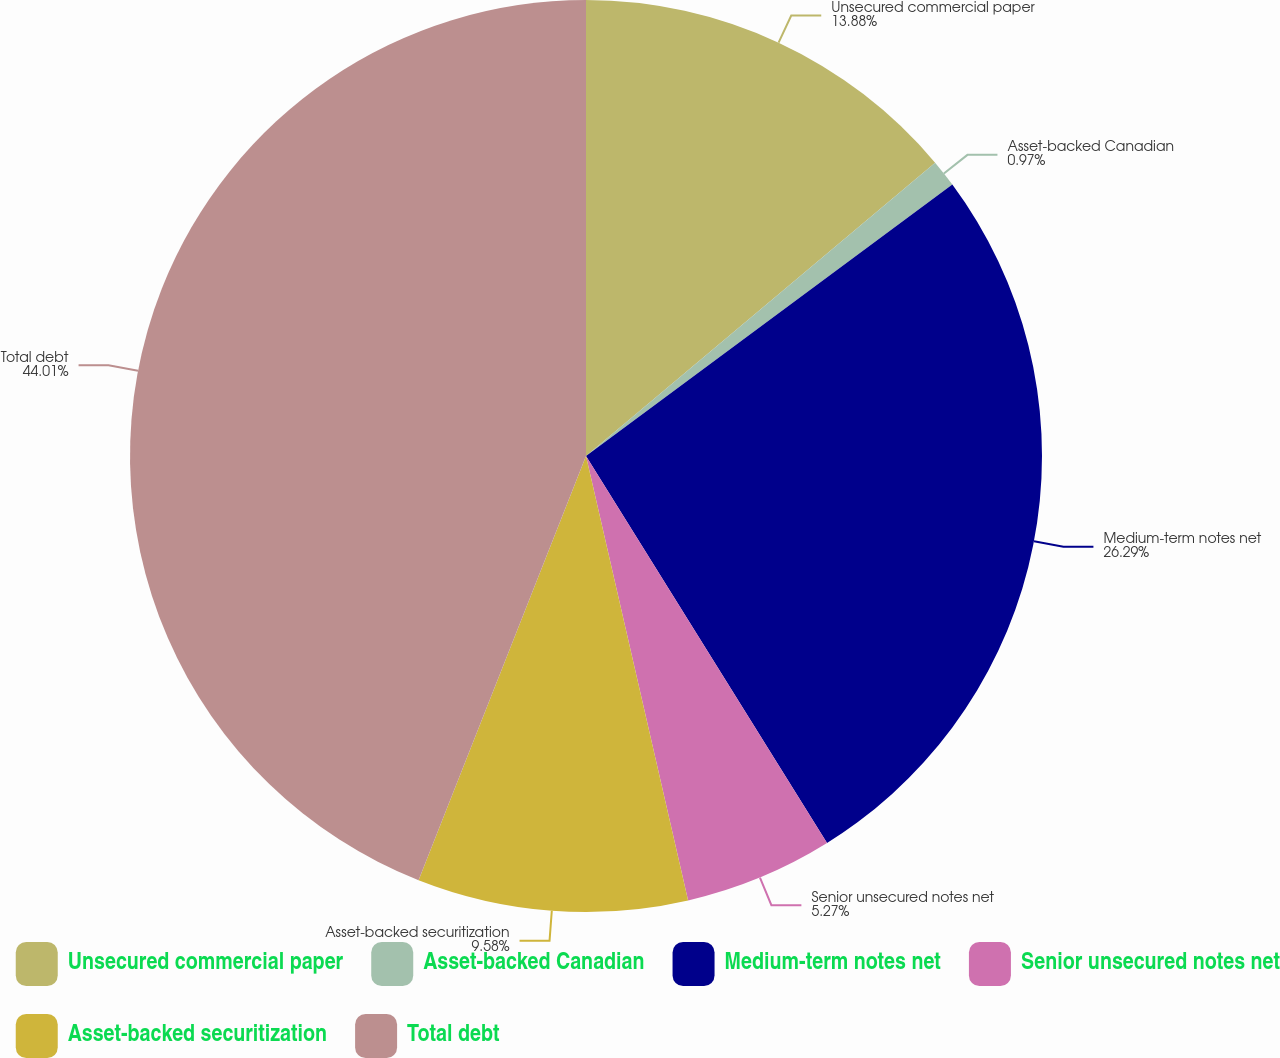Convert chart to OTSL. <chart><loc_0><loc_0><loc_500><loc_500><pie_chart><fcel>Unsecured commercial paper<fcel>Asset-backed Canadian<fcel>Medium-term notes net<fcel>Senior unsecured notes net<fcel>Asset-backed securitization<fcel>Total debt<nl><fcel>13.88%<fcel>0.97%<fcel>26.29%<fcel>5.27%<fcel>9.58%<fcel>44.02%<nl></chart> 